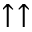Convert formula to latex. <formula><loc_0><loc_0><loc_500><loc_500>\uparrow \uparrow</formula> 